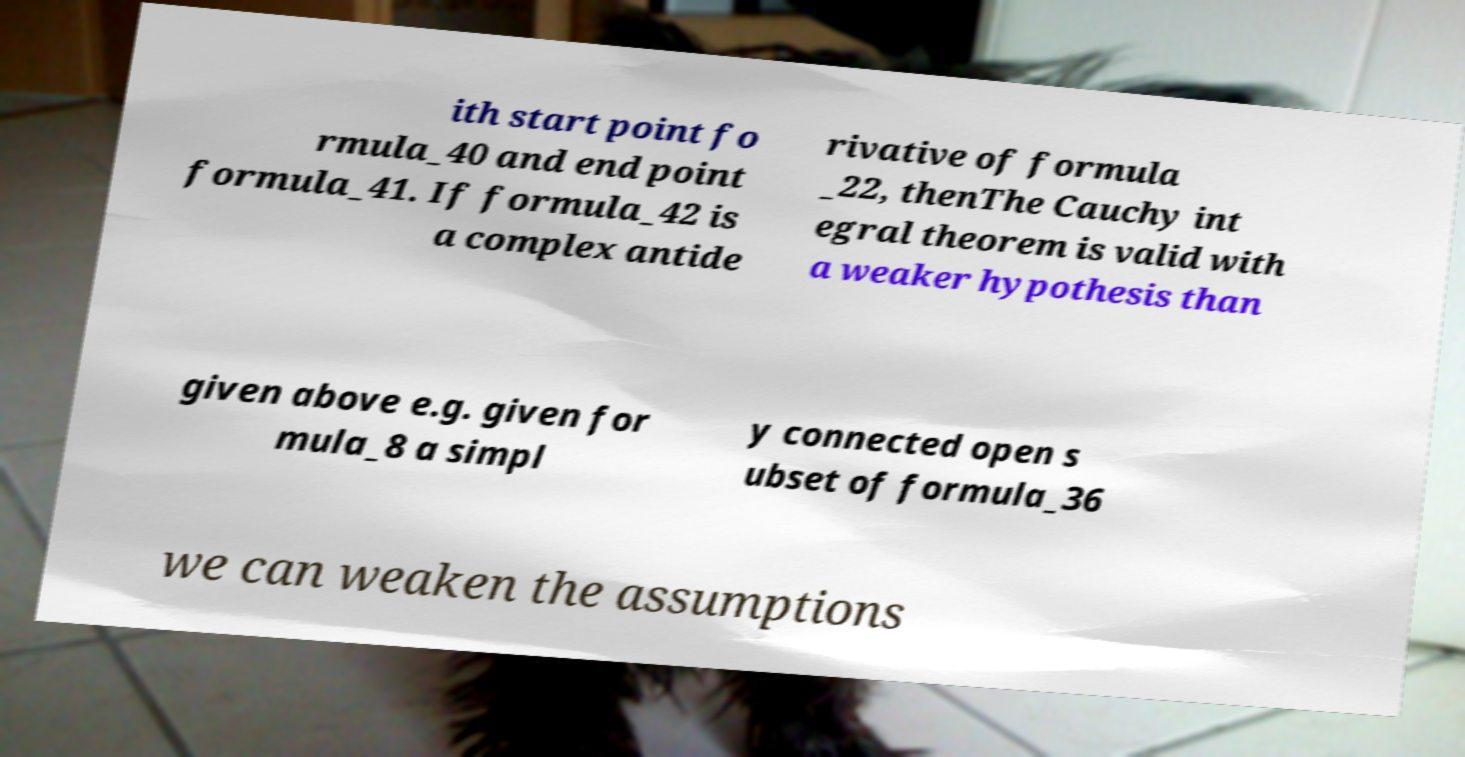Please identify and transcribe the text found in this image. ith start point fo rmula_40 and end point formula_41. If formula_42 is a complex antide rivative of formula _22, thenThe Cauchy int egral theorem is valid with a weaker hypothesis than given above e.g. given for mula_8 a simpl y connected open s ubset of formula_36 we can weaken the assumptions 